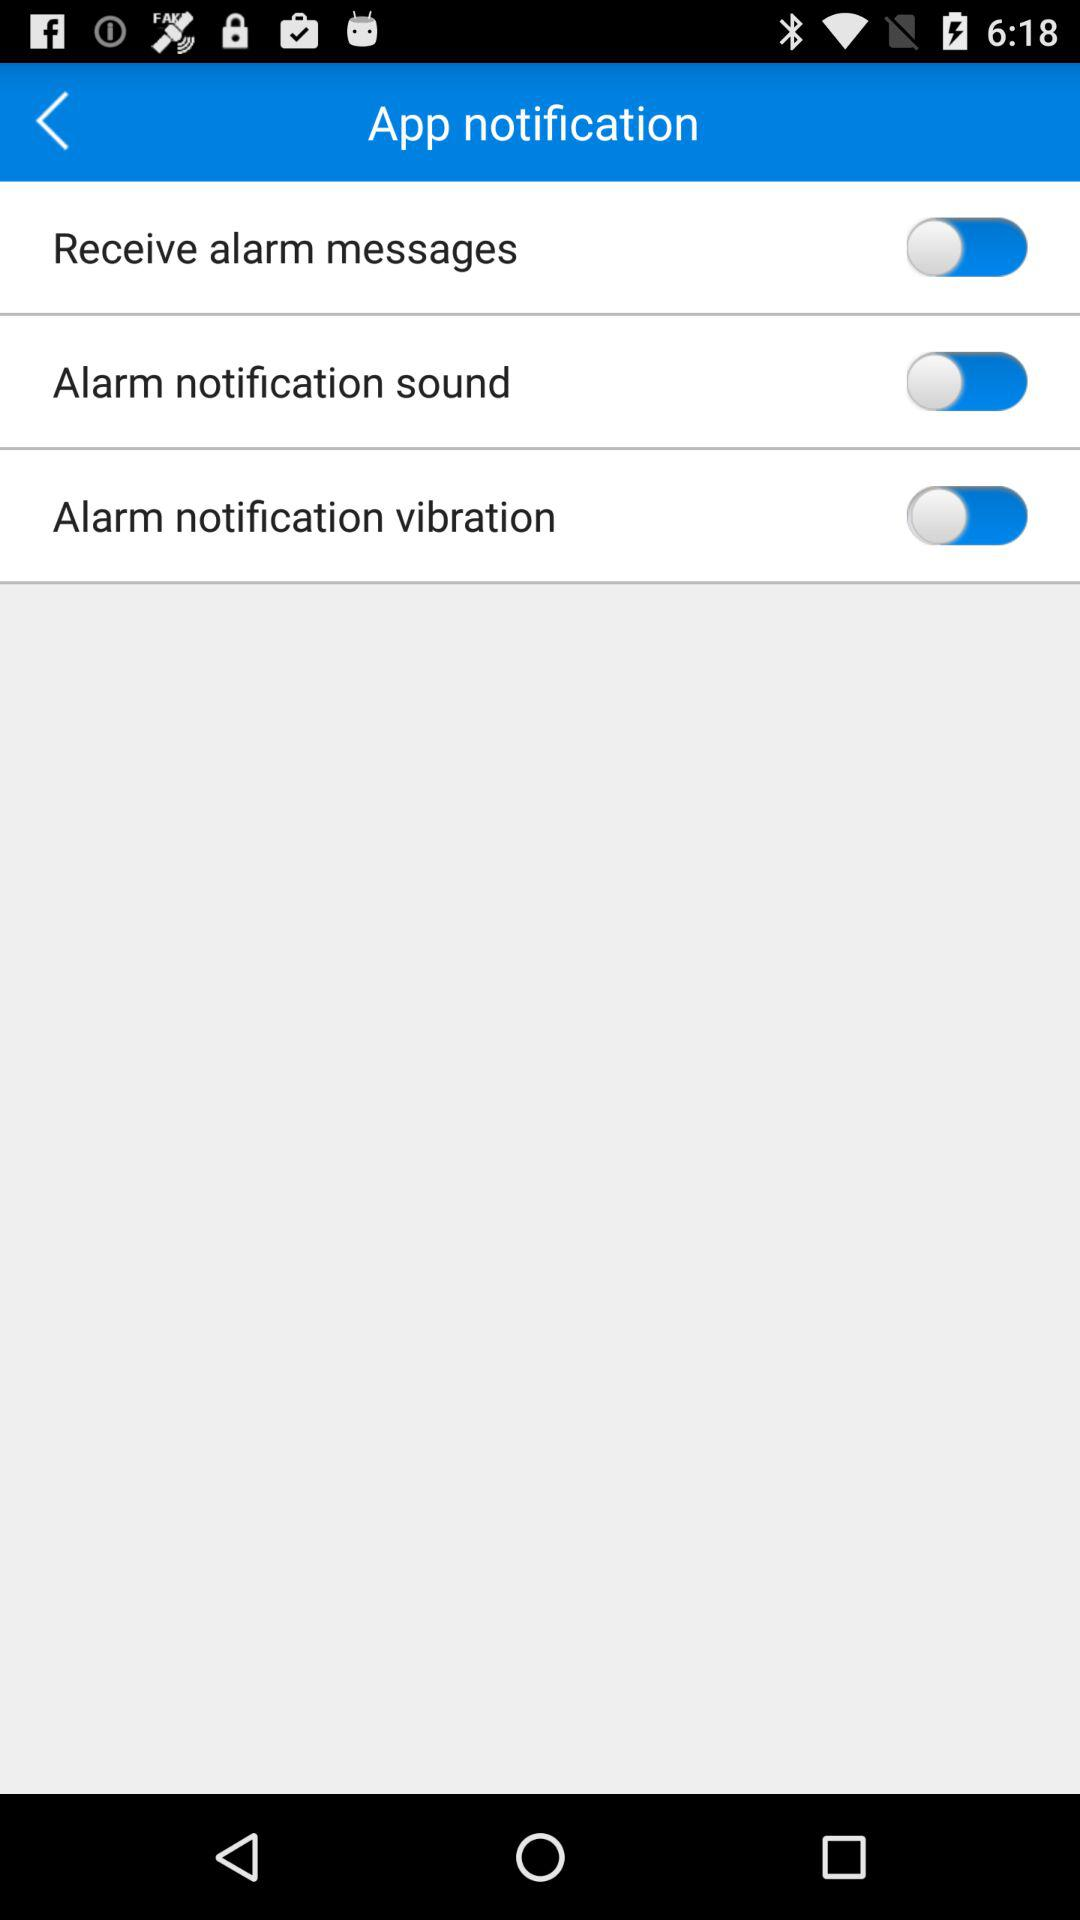What's the status of "Receive alarm messages"? The status of "Receive alarm messages" is "off". 